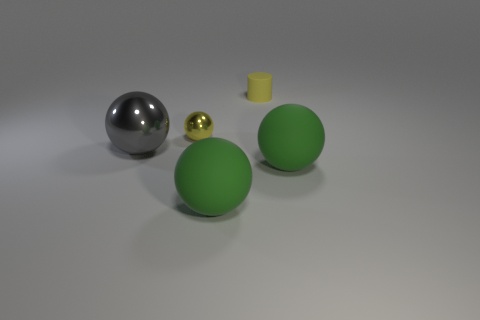How many other tiny objects have the same color as the small rubber object?
Keep it short and to the point. 1. The metal sphere that is on the right side of the large gray object is what color?
Make the answer very short. Yellow. Is the gray object the same shape as the yellow rubber object?
Your answer should be very brief. No. What color is the object that is behind the large gray ball and on the right side of the small ball?
Provide a succinct answer. Yellow. There is a thing that is left of the tiny yellow metallic object; does it have the same size as the matte object to the left of the small yellow rubber cylinder?
Keep it short and to the point. Yes. What number of objects are either objects that are behind the tiny yellow metal thing or tiny purple cubes?
Your answer should be very brief. 1. What is the tiny yellow sphere made of?
Make the answer very short. Metal. Do the yellow matte object and the yellow metallic object have the same size?
Your answer should be very brief. Yes. How many blocks are either small yellow rubber objects or yellow metal things?
Keep it short and to the point. 0. The rubber ball right of the matte thing on the left side of the matte cylinder is what color?
Provide a short and direct response. Green. 